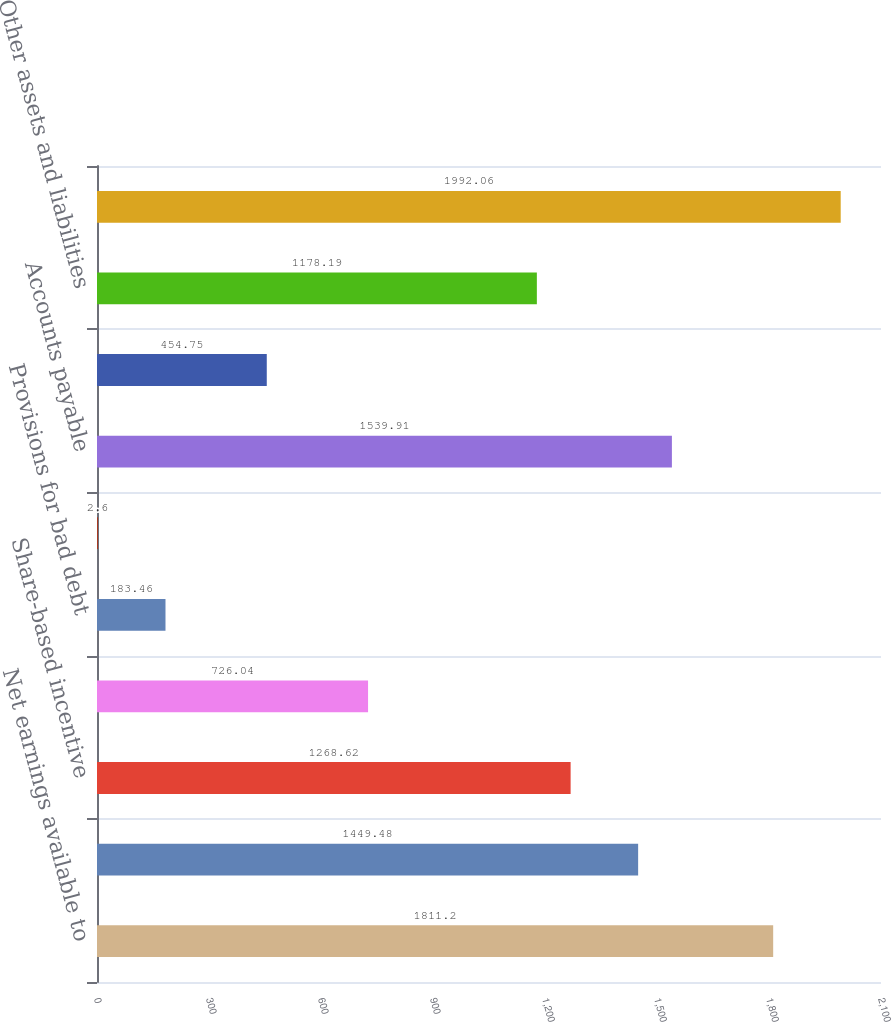Convert chart. <chart><loc_0><loc_0><loc_500><loc_500><bar_chart><fcel>Net earnings available to<fcel>Depreciation and amortization<fcel>Share-based incentive<fcel>Profit sharing expense<fcel>Provisions for bad debt<fcel>Changes in operating assets<fcel>Accounts payable<fcel>Income tax receivable/payable<fcel>Other assets and liabilities<fcel>Net cash provided by operating<nl><fcel>1811.2<fcel>1449.48<fcel>1268.62<fcel>726.04<fcel>183.46<fcel>2.6<fcel>1539.91<fcel>454.75<fcel>1178.19<fcel>1992.06<nl></chart> 